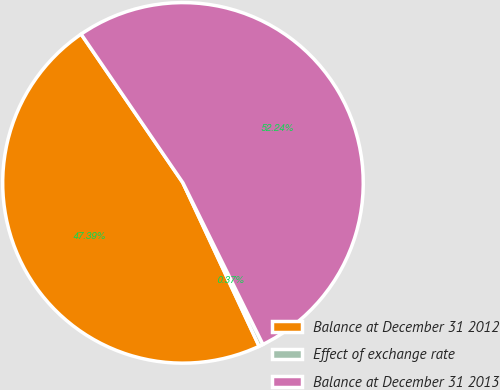Convert chart. <chart><loc_0><loc_0><loc_500><loc_500><pie_chart><fcel>Balance at December 31 2012<fcel>Effect of exchange rate<fcel>Balance at December 31 2013<nl><fcel>47.39%<fcel>0.37%<fcel>52.24%<nl></chart> 